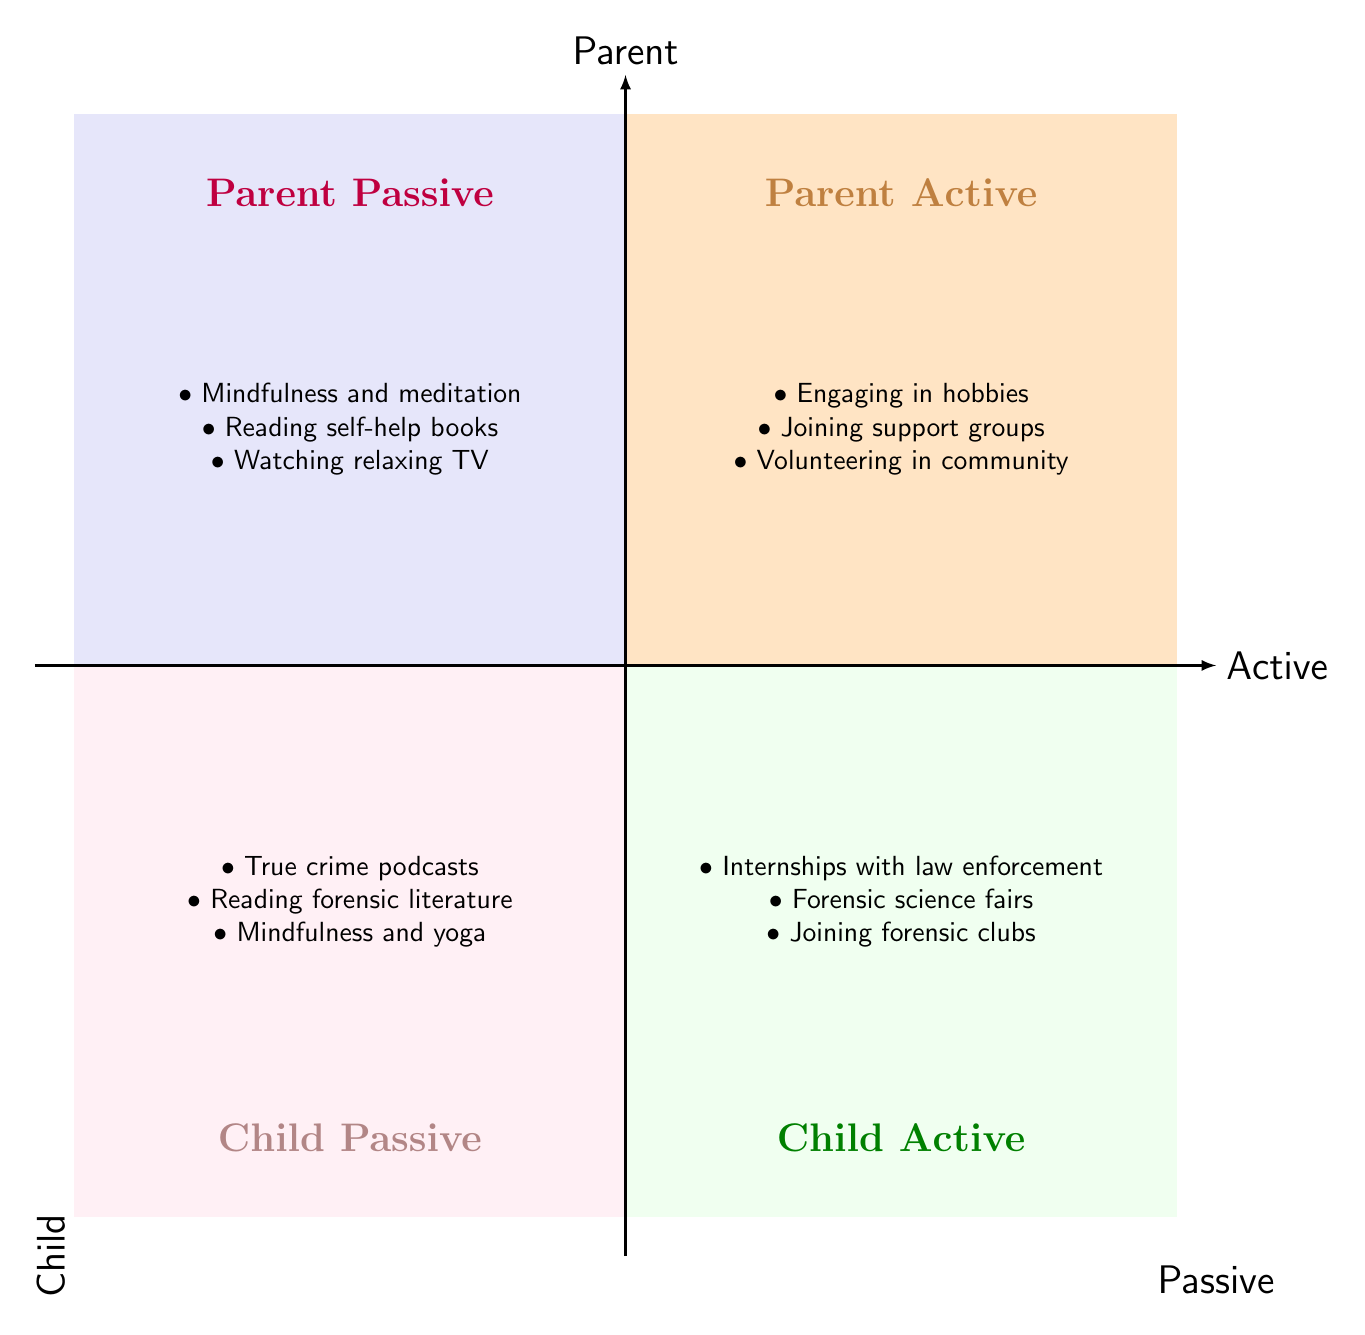What are the elements listed under Parent Active? The elements in the Parent Active quadrant are listed directly in the diagram, which include "Engaging in hobbies," "Joining support groups for parents," and "Volunteering in community work."
Answer: Engaging in hobbies, Joining support groups for parents, Volunteering in community work How many elements are in the Child Passive quadrant? Counting the elements listed in the Child Passive quadrant, we see three: "Listening to true crime podcasts," "Reading forensic science literature," and "Mindfulness and yoga practices."
Answer: 3 Which quadrant contains activities related to mindfulness for parents? Mindfulness and meditation activities for parents are located in the Parent Passive quadrant as stated in the diagram.
Answer: Parent Passive What is the title of Quadrant 3? The title of Quadrant 3, which corresponds to activities of children, is clearly marked as "Child Active" in the diagram.
Answer: Child Active What are the main activities for children in active coping mechanisms? The Child Active quadrant lists "Internships with law enforcement agencies," "Participating in forensic science fairs," and "Joining college forensic clubs" as its primary activities for children.
Answer: Internships with law enforcement agencies, Participating in forensic science fairs, Joining college forensic clubs Which quadrant focuses on passive coping mechanisms for parents? The quadrant dedicated to passive coping mechanisms for parents, as indicated in the diagram, is the Parent Passive quadrant.
Answer: Parent Passive Which quadrant features activities related to forensics for children? The Child Active quadrant highlights activities specifically related to forensics, including participating in forensic science fairs and joining forensic clubs.
Answer: Child Active Can you identify which quadrant has the most engaging activities overall? Analyzing the quadrants, the Parent Active and Child Active quadrants both contain engaging activities, but the Child Active quadrant focuses specifically on activities that can also enhance career prospects in forensic science, making it notably engaging.
Answer: Child Active 